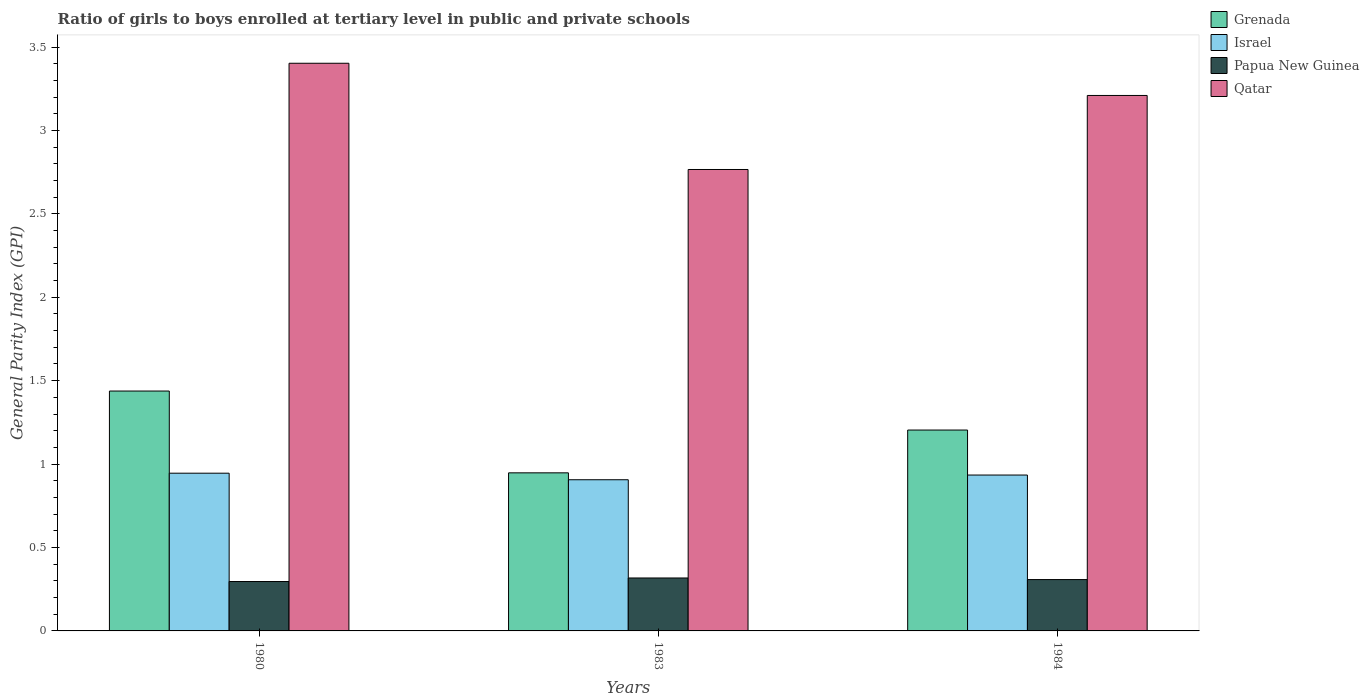How many different coloured bars are there?
Offer a terse response. 4. Are the number of bars on each tick of the X-axis equal?
Ensure brevity in your answer.  Yes. How many bars are there on the 2nd tick from the left?
Provide a succinct answer. 4. In how many cases, is the number of bars for a given year not equal to the number of legend labels?
Your response must be concise. 0. What is the general parity index in Papua New Guinea in 1984?
Ensure brevity in your answer.  0.31. Across all years, what is the maximum general parity index in Qatar?
Provide a succinct answer. 3.4. Across all years, what is the minimum general parity index in Papua New Guinea?
Make the answer very short. 0.3. What is the total general parity index in Israel in the graph?
Give a very brief answer. 2.79. What is the difference between the general parity index in Grenada in 1980 and that in 1983?
Offer a terse response. 0.49. What is the difference between the general parity index in Israel in 1983 and the general parity index in Qatar in 1984?
Your answer should be very brief. -2.3. What is the average general parity index in Qatar per year?
Your answer should be very brief. 3.13. In the year 1980, what is the difference between the general parity index in Grenada and general parity index in Israel?
Ensure brevity in your answer.  0.49. In how many years, is the general parity index in Qatar greater than 0.7?
Your answer should be very brief. 3. What is the ratio of the general parity index in Israel in 1983 to that in 1984?
Offer a very short reply. 0.97. What is the difference between the highest and the second highest general parity index in Grenada?
Give a very brief answer. 0.23. What is the difference between the highest and the lowest general parity index in Israel?
Ensure brevity in your answer.  0.04. What does the 1st bar from the left in 1983 represents?
Ensure brevity in your answer.  Grenada. What does the 2nd bar from the right in 1984 represents?
Ensure brevity in your answer.  Papua New Guinea. Is it the case that in every year, the sum of the general parity index in Qatar and general parity index in Grenada is greater than the general parity index in Papua New Guinea?
Offer a terse response. Yes. How many bars are there?
Give a very brief answer. 12. Are all the bars in the graph horizontal?
Provide a succinct answer. No. How many years are there in the graph?
Keep it short and to the point. 3. Are the values on the major ticks of Y-axis written in scientific E-notation?
Your response must be concise. No. Does the graph contain grids?
Your answer should be very brief. No. How many legend labels are there?
Provide a succinct answer. 4. How are the legend labels stacked?
Offer a very short reply. Vertical. What is the title of the graph?
Provide a short and direct response. Ratio of girls to boys enrolled at tertiary level in public and private schools. Does "Zimbabwe" appear as one of the legend labels in the graph?
Offer a very short reply. No. What is the label or title of the X-axis?
Keep it short and to the point. Years. What is the label or title of the Y-axis?
Ensure brevity in your answer.  General Parity Index (GPI). What is the General Parity Index (GPI) of Grenada in 1980?
Provide a succinct answer. 1.44. What is the General Parity Index (GPI) in Israel in 1980?
Keep it short and to the point. 0.95. What is the General Parity Index (GPI) of Papua New Guinea in 1980?
Your answer should be compact. 0.3. What is the General Parity Index (GPI) of Qatar in 1980?
Your answer should be very brief. 3.4. What is the General Parity Index (GPI) of Grenada in 1983?
Your answer should be very brief. 0.95. What is the General Parity Index (GPI) of Israel in 1983?
Offer a terse response. 0.91. What is the General Parity Index (GPI) of Papua New Guinea in 1983?
Give a very brief answer. 0.32. What is the General Parity Index (GPI) of Qatar in 1983?
Give a very brief answer. 2.77. What is the General Parity Index (GPI) in Grenada in 1984?
Offer a terse response. 1.2. What is the General Parity Index (GPI) of Israel in 1984?
Offer a terse response. 0.93. What is the General Parity Index (GPI) in Papua New Guinea in 1984?
Your answer should be very brief. 0.31. What is the General Parity Index (GPI) of Qatar in 1984?
Your response must be concise. 3.21. Across all years, what is the maximum General Parity Index (GPI) in Grenada?
Keep it short and to the point. 1.44. Across all years, what is the maximum General Parity Index (GPI) of Israel?
Keep it short and to the point. 0.95. Across all years, what is the maximum General Parity Index (GPI) in Papua New Guinea?
Your answer should be very brief. 0.32. Across all years, what is the maximum General Parity Index (GPI) in Qatar?
Make the answer very short. 3.4. Across all years, what is the minimum General Parity Index (GPI) in Grenada?
Give a very brief answer. 0.95. Across all years, what is the minimum General Parity Index (GPI) of Israel?
Provide a succinct answer. 0.91. Across all years, what is the minimum General Parity Index (GPI) of Papua New Guinea?
Ensure brevity in your answer.  0.3. Across all years, what is the minimum General Parity Index (GPI) in Qatar?
Your answer should be compact. 2.77. What is the total General Parity Index (GPI) in Grenada in the graph?
Provide a succinct answer. 3.59. What is the total General Parity Index (GPI) of Israel in the graph?
Provide a short and direct response. 2.79. What is the total General Parity Index (GPI) of Papua New Guinea in the graph?
Provide a short and direct response. 0.92. What is the total General Parity Index (GPI) of Qatar in the graph?
Offer a very short reply. 9.38. What is the difference between the General Parity Index (GPI) of Grenada in 1980 and that in 1983?
Keep it short and to the point. 0.49. What is the difference between the General Parity Index (GPI) of Israel in 1980 and that in 1983?
Provide a succinct answer. 0.04. What is the difference between the General Parity Index (GPI) in Papua New Guinea in 1980 and that in 1983?
Offer a very short reply. -0.02. What is the difference between the General Parity Index (GPI) in Qatar in 1980 and that in 1983?
Keep it short and to the point. 0.64. What is the difference between the General Parity Index (GPI) in Grenada in 1980 and that in 1984?
Offer a very short reply. 0.23. What is the difference between the General Parity Index (GPI) of Israel in 1980 and that in 1984?
Your response must be concise. 0.01. What is the difference between the General Parity Index (GPI) of Papua New Guinea in 1980 and that in 1984?
Ensure brevity in your answer.  -0.01. What is the difference between the General Parity Index (GPI) in Qatar in 1980 and that in 1984?
Provide a short and direct response. 0.19. What is the difference between the General Parity Index (GPI) of Grenada in 1983 and that in 1984?
Keep it short and to the point. -0.26. What is the difference between the General Parity Index (GPI) of Israel in 1983 and that in 1984?
Ensure brevity in your answer.  -0.03. What is the difference between the General Parity Index (GPI) in Papua New Guinea in 1983 and that in 1984?
Keep it short and to the point. 0.01. What is the difference between the General Parity Index (GPI) in Qatar in 1983 and that in 1984?
Ensure brevity in your answer.  -0.44. What is the difference between the General Parity Index (GPI) of Grenada in 1980 and the General Parity Index (GPI) of Israel in 1983?
Give a very brief answer. 0.53. What is the difference between the General Parity Index (GPI) of Grenada in 1980 and the General Parity Index (GPI) of Papua New Guinea in 1983?
Provide a succinct answer. 1.12. What is the difference between the General Parity Index (GPI) in Grenada in 1980 and the General Parity Index (GPI) in Qatar in 1983?
Provide a short and direct response. -1.33. What is the difference between the General Parity Index (GPI) of Israel in 1980 and the General Parity Index (GPI) of Papua New Guinea in 1983?
Your answer should be compact. 0.63. What is the difference between the General Parity Index (GPI) in Israel in 1980 and the General Parity Index (GPI) in Qatar in 1983?
Your answer should be very brief. -1.82. What is the difference between the General Parity Index (GPI) of Papua New Guinea in 1980 and the General Parity Index (GPI) of Qatar in 1983?
Ensure brevity in your answer.  -2.47. What is the difference between the General Parity Index (GPI) in Grenada in 1980 and the General Parity Index (GPI) in Israel in 1984?
Keep it short and to the point. 0.5. What is the difference between the General Parity Index (GPI) in Grenada in 1980 and the General Parity Index (GPI) in Papua New Guinea in 1984?
Offer a very short reply. 1.13. What is the difference between the General Parity Index (GPI) in Grenada in 1980 and the General Parity Index (GPI) in Qatar in 1984?
Keep it short and to the point. -1.77. What is the difference between the General Parity Index (GPI) in Israel in 1980 and the General Parity Index (GPI) in Papua New Guinea in 1984?
Your answer should be very brief. 0.64. What is the difference between the General Parity Index (GPI) in Israel in 1980 and the General Parity Index (GPI) in Qatar in 1984?
Provide a succinct answer. -2.26. What is the difference between the General Parity Index (GPI) of Papua New Guinea in 1980 and the General Parity Index (GPI) of Qatar in 1984?
Give a very brief answer. -2.91. What is the difference between the General Parity Index (GPI) in Grenada in 1983 and the General Parity Index (GPI) in Israel in 1984?
Provide a succinct answer. 0.01. What is the difference between the General Parity Index (GPI) of Grenada in 1983 and the General Parity Index (GPI) of Papua New Guinea in 1984?
Keep it short and to the point. 0.64. What is the difference between the General Parity Index (GPI) of Grenada in 1983 and the General Parity Index (GPI) of Qatar in 1984?
Your answer should be compact. -2.26. What is the difference between the General Parity Index (GPI) in Israel in 1983 and the General Parity Index (GPI) in Papua New Guinea in 1984?
Make the answer very short. 0.6. What is the difference between the General Parity Index (GPI) in Israel in 1983 and the General Parity Index (GPI) in Qatar in 1984?
Ensure brevity in your answer.  -2.3. What is the difference between the General Parity Index (GPI) of Papua New Guinea in 1983 and the General Parity Index (GPI) of Qatar in 1984?
Make the answer very short. -2.89. What is the average General Parity Index (GPI) in Grenada per year?
Your answer should be very brief. 1.2. What is the average General Parity Index (GPI) of Israel per year?
Provide a short and direct response. 0.93. What is the average General Parity Index (GPI) in Papua New Guinea per year?
Make the answer very short. 0.31. What is the average General Parity Index (GPI) in Qatar per year?
Offer a terse response. 3.13. In the year 1980, what is the difference between the General Parity Index (GPI) in Grenada and General Parity Index (GPI) in Israel?
Provide a succinct answer. 0.49. In the year 1980, what is the difference between the General Parity Index (GPI) of Grenada and General Parity Index (GPI) of Papua New Guinea?
Make the answer very short. 1.14. In the year 1980, what is the difference between the General Parity Index (GPI) in Grenada and General Parity Index (GPI) in Qatar?
Provide a succinct answer. -1.96. In the year 1980, what is the difference between the General Parity Index (GPI) of Israel and General Parity Index (GPI) of Papua New Guinea?
Keep it short and to the point. 0.65. In the year 1980, what is the difference between the General Parity Index (GPI) in Israel and General Parity Index (GPI) in Qatar?
Your response must be concise. -2.46. In the year 1980, what is the difference between the General Parity Index (GPI) of Papua New Guinea and General Parity Index (GPI) of Qatar?
Keep it short and to the point. -3.11. In the year 1983, what is the difference between the General Parity Index (GPI) of Grenada and General Parity Index (GPI) of Israel?
Your response must be concise. 0.04. In the year 1983, what is the difference between the General Parity Index (GPI) in Grenada and General Parity Index (GPI) in Papua New Guinea?
Ensure brevity in your answer.  0.63. In the year 1983, what is the difference between the General Parity Index (GPI) of Grenada and General Parity Index (GPI) of Qatar?
Your answer should be very brief. -1.82. In the year 1983, what is the difference between the General Parity Index (GPI) in Israel and General Parity Index (GPI) in Papua New Guinea?
Your answer should be very brief. 0.59. In the year 1983, what is the difference between the General Parity Index (GPI) of Israel and General Parity Index (GPI) of Qatar?
Give a very brief answer. -1.86. In the year 1983, what is the difference between the General Parity Index (GPI) of Papua New Guinea and General Parity Index (GPI) of Qatar?
Make the answer very short. -2.45. In the year 1984, what is the difference between the General Parity Index (GPI) of Grenada and General Parity Index (GPI) of Israel?
Offer a terse response. 0.27. In the year 1984, what is the difference between the General Parity Index (GPI) in Grenada and General Parity Index (GPI) in Papua New Guinea?
Ensure brevity in your answer.  0.9. In the year 1984, what is the difference between the General Parity Index (GPI) in Grenada and General Parity Index (GPI) in Qatar?
Offer a terse response. -2.01. In the year 1984, what is the difference between the General Parity Index (GPI) in Israel and General Parity Index (GPI) in Papua New Guinea?
Your response must be concise. 0.63. In the year 1984, what is the difference between the General Parity Index (GPI) in Israel and General Parity Index (GPI) in Qatar?
Keep it short and to the point. -2.28. In the year 1984, what is the difference between the General Parity Index (GPI) in Papua New Guinea and General Parity Index (GPI) in Qatar?
Your answer should be compact. -2.9. What is the ratio of the General Parity Index (GPI) in Grenada in 1980 to that in 1983?
Your answer should be very brief. 1.52. What is the ratio of the General Parity Index (GPI) of Israel in 1980 to that in 1983?
Give a very brief answer. 1.04. What is the ratio of the General Parity Index (GPI) of Papua New Guinea in 1980 to that in 1983?
Offer a very short reply. 0.93. What is the ratio of the General Parity Index (GPI) in Qatar in 1980 to that in 1983?
Ensure brevity in your answer.  1.23. What is the ratio of the General Parity Index (GPI) in Grenada in 1980 to that in 1984?
Provide a short and direct response. 1.19. What is the ratio of the General Parity Index (GPI) in Israel in 1980 to that in 1984?
Give a very brief answer. 1.01. What is the ratio of the General Parity Index (GPI) in Papua New Guinea in 1980 to that in 1984?
Offer a very short reply. 0.96. What is the ratio of the General Parity Index (GPI) of Qatar in 1980 to that in 1984?
Offer a terse response. 1.06. What is the ratio of the General Parity Index (GPI) in Grenada in 1983 to that in 1984?
Offer a terse response. 0.79. What is the ratio of the General Parity Index (GPI) in Israel in 1983 to that in 1984?
Your answer should be compact. 0.97. What is the ratio of the General Parity Index (GPI) of Papua New Guinea in 1983 to that in 1984?
Offer a very short reply. 1.03. What is the ratio of the General Parity Index (GPI) in Qatar in 1983 to that in 1984?
Your response must be concise. 0.86. What is the difference between the highest and the second highest General Parity Index (GPI) of Grenada?
Your answer should be compact. 0.23. What is the difference between the highest and the second highest General Parity Index (GPI) in Israel?
Provide a succinct answer. 0.01. What is the difference between the highest and the second highest General Parity Index (GPI) in Papua New Guinea?
Provide a succinct answer. 0.01. What is the difference between the highest and the second highest General Parity Index (GPI) of Qatar?
Give a very brief answer. 0.19. What is the difference between the highest and the lowest General Parity Index (GPI) of Grenada?
Ensure brevity in your answer.  0.49. What is the difference between the highest and the lowest General Parity Index (GPI) in Israel?
Give a very brief answer. 0.04. What is the difference between the highest and the lowest General Parity Index (GPI) of Papua New Guinea?
Your answer should be compact. 0.02. What is the difference between the highest and the lowest General Parity Index (GPI) of Qatar?
Give a very brief answer. 0.64. 